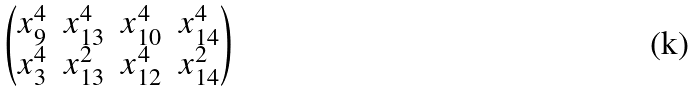<formula> <loc_0><loc_0><loc_500><loc_500>\begin{pmatrix} x _ { 9 } ^ { 4 } & x _ { 1 3 } ^ { 4 } & x _ { 1 0 } ^ { 4 } & x _ { 1 4 } ^ { 4 } \\ x _ { 3 } ^ { 4 } & x _ { 1 3 } ^ { 2 } & x _ { 1 2 } ^ { 4 } & x _ { 1 4 } ^ { 2 } \end{pmatrix}</formula> 